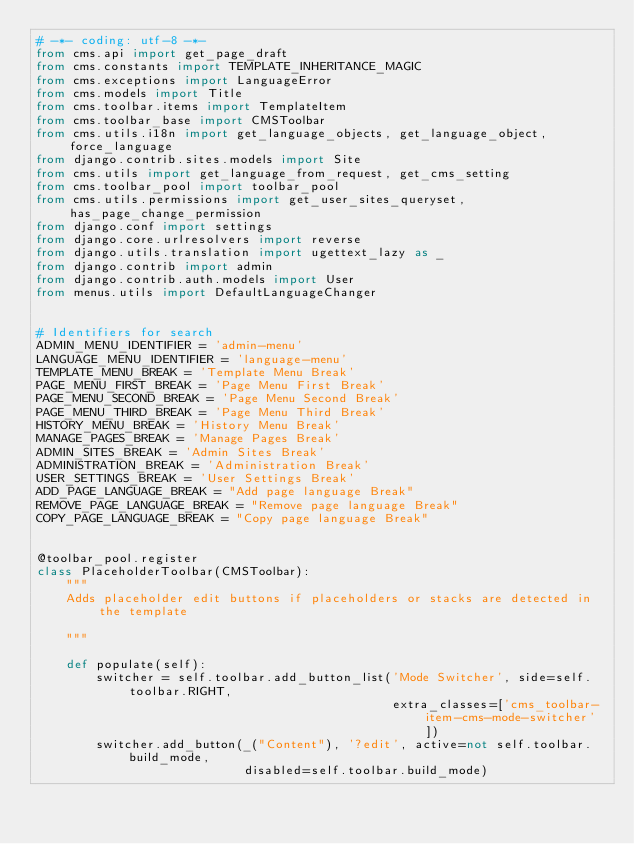Convert code to text. <code><loc_0><loc_0><loc_500><loc_500><_Python_># -*- coding: utf-8 -*-
from cms.api import get_page_draft
from cms.constants import TEMPLATE_INHERITANCE_MAGIC
from cms.exceptions import LanguageError
from cms.models import Title
from cms.toolbar.items import TemplateItem
from cms.toolbar_base import CMSToolbar
from cms.utils.i18n import get_language_objects, get_language_object, force_language
from django.contrib.sites.models import Site
from cms.utils import get_language_from_request, get_cms_setting
from cms.toolbar_pool import toolbar_pool
from cms.utils.permissions import get_user_sites_queryset, has_page_change_permission
from django.conf import settings
from django.core.urlresolvers import reverse
from django.utils.translation import ugettext_lazy as _
from django.contrib import admin
from django.contrib.auth.models import User
from menus.utils import DefaultLanguageChanger


# Identifiers for search
ADMIN_MENU_IDENTIFIER = 'admin-menu'
LANGUAGE_MENU_IDENTIFIER = 'language-menu'
TEMPLATE_MENU_BREAK = 'Template Menu Break'
PAGE_MENU_FIRST_BREAK = 'Page Menu First Break'
PAGE_MENU_SECOND_BREAK = 'Page Menu Second Break'
PAGE_MENU_THIRD_BREAK = 'Page Menu Third Break'
HISTORY_MENU_BREAK = 'History Menu Break'
MANAGE_PAGES_BREAK = 'Manage Pages Break'
ADMIN_SITES_BREAK = 'Admin Sites Break'
ADMINISTRATION_BREAK = 'Administration Break'
USER_SETTINGS_BREAK = 'User Settings Break'
ADD_PAGE_LANGUAGE_BREAK = "Add page language Break"
REMOVE_PAGE_LANGUAGE_BREAK = "Remove page language Break"
COPY_PAGE_LANGUAGE_BREAK = "Copy page language Break"


@toolbar_pool.register
class PlaceholderToolbar(CMSToolbar):
    """
    Adds placeholder edit buttons if placeholders or stacks are detected in the template

    """

    def populate(self):
        switcher = self.toolbar.add_button_list('Mode Switcher', side=self.toolbar.RIGHT,
                                                extra_classes=['cms_toolbar-item-cms-mode-switcher'])
        switcher.add_button(_("Content"), '?edit', active=not self.toolbar.build_mode,
                            disabled=self.toolbar.build_mode)</code> 